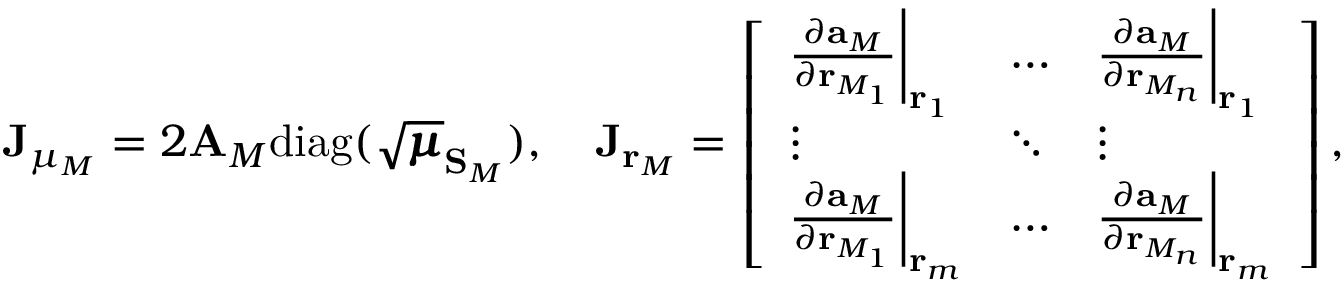<formula> <loc_0><loc_0><loc_500><loc_500>J _ { \mu _ { M } } = 2 A _ { M } d i a g ( \sqrt { \pm b { \mu } } _ { S _ { M } } ) , \quad J _ { r _ { M } } = \left [ \begin{array} { l l l } { \frac { \partial { a _ { M } } } { \partial r _ { M _ { 1 } } } \left | _ { r _ { 1 } } } & { \hdots } & { \frac { \partial { a _ { M } } } { \partial r _ { M _ { n } } } \right | _ { r _ { 1 } } } \\ { \vdots } & { \ddots } & { \vdots } \\ { \frac { \partial { a _ { M } } } { \partial r _ { M _ { 1 } } } \left | _ { r _ { m } } } & { \hdots } & { \frac { \partial { a _ { M } } } { \partial r _ { M _ { n } } } \right | _ { r _ { m } } } \end{array} \right ] ,</formula> 